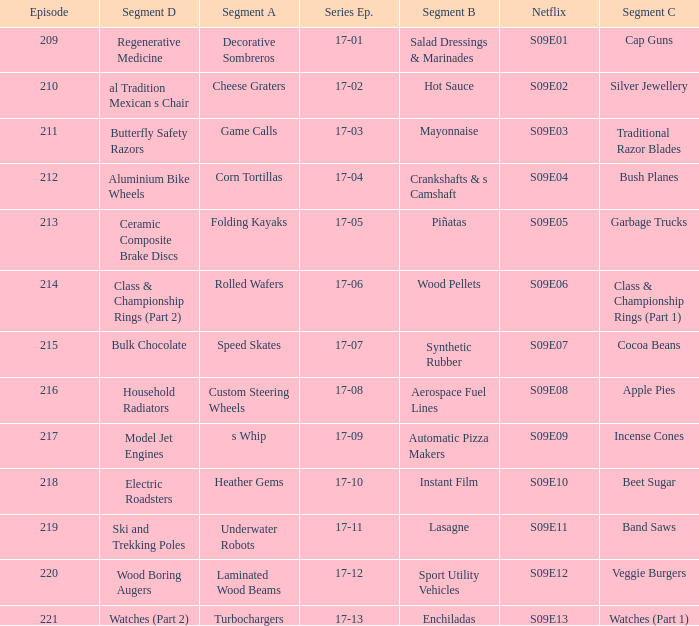Segment A of heather gems is what netflix episode? S09E10. 